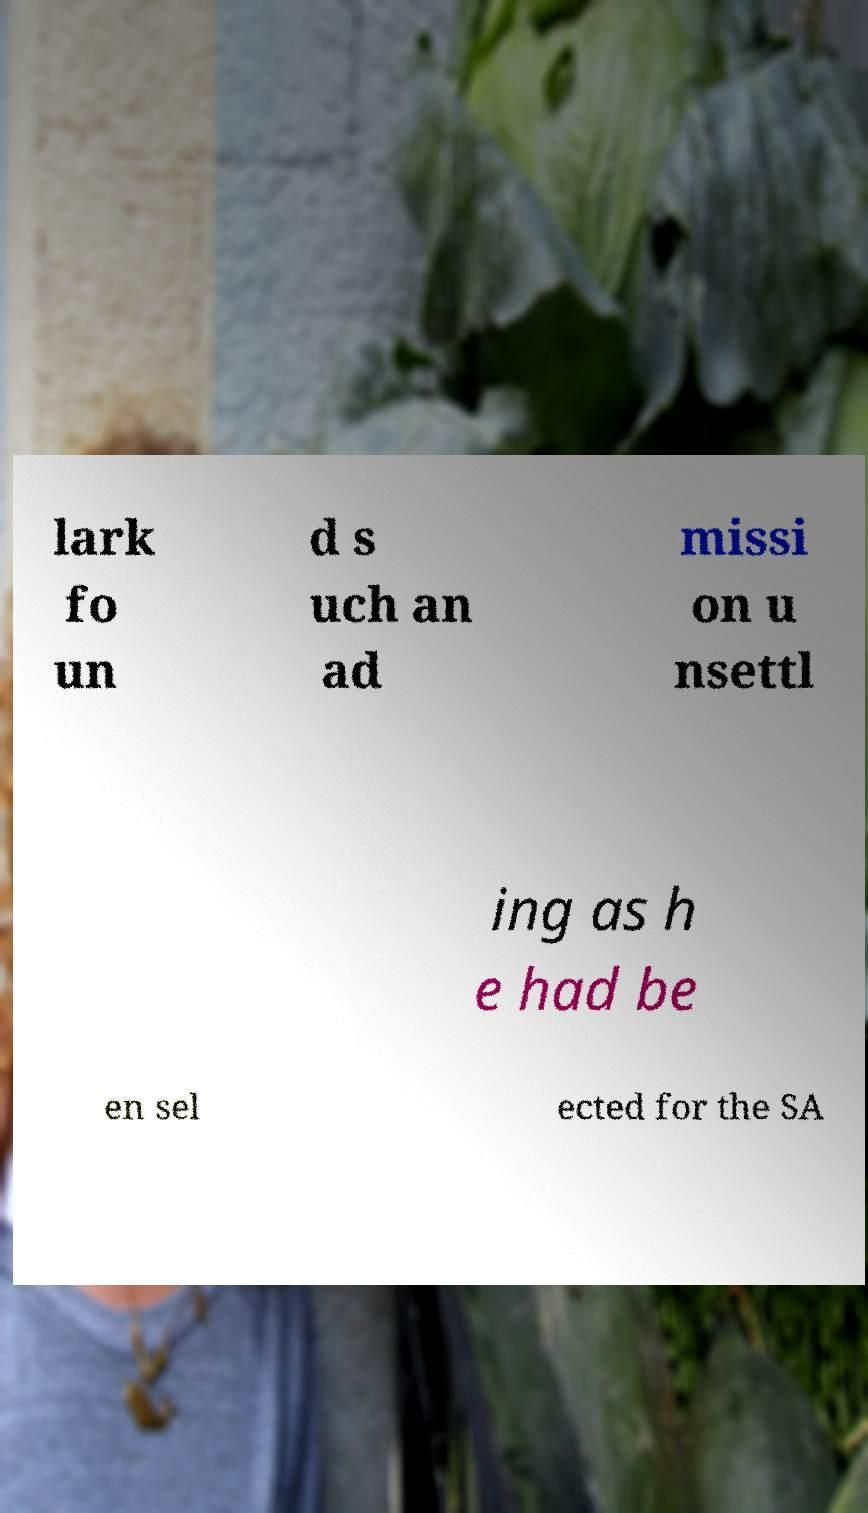Could you extract and type out the text from this image? lark fo un d s uch an ad missi on u nsettl ing as h e had be en sel ected for the SA 